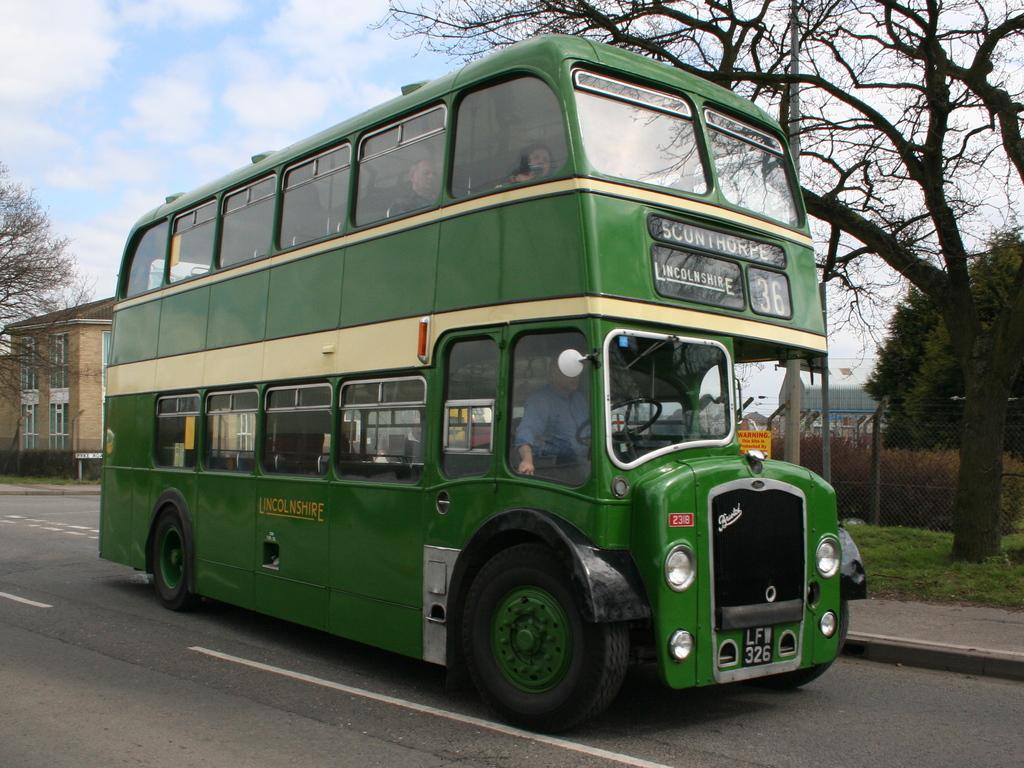<image>
Present a compact description of the photo's key features. Green double decker bus going to Sconthorpe on the road. 